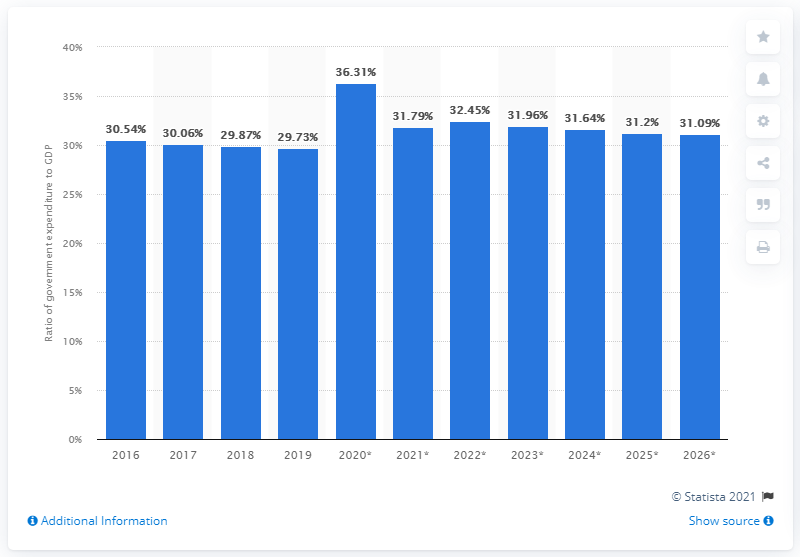Mention a couple of crucial points in this snapshot. In 2019, government expenditure accounted for 29.73% of Morocco's Gross Domestic Product (GDP). 